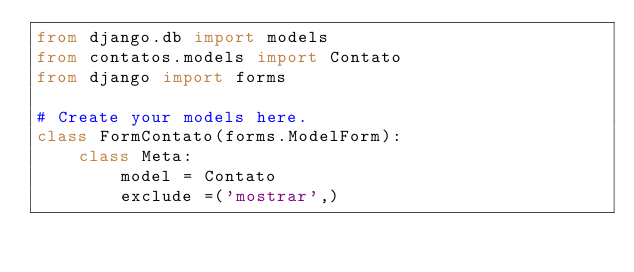<code> <loc_0><loc_0><loc_500><loc_500><_Python_>from django.db import models
from contatos.models import Contato
from django import forms

# Create your models here.
class FormContato(forms.ModelForm):
    class Meta:
        model = Contato
        exclude =('mostrar',)</code> 